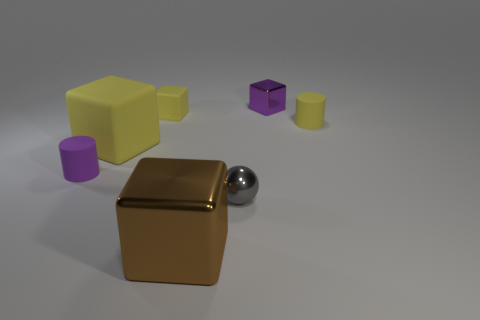Subtract all yellow balls. How many yellow blocks are left? 2 Subtract all big matte blocks. How many blocks are left? 3 Subtract all brown cubes. How many cubes are left? 3 Subtract 1 cubes. How many cubes are left? 3 Add 3 small metallic spheres. How many objects exist? 10 Subtract all green blocks. Subtract all gray balls. How many blocks are left? 4 Subtract all cubes. How many objects are left? 3 Subtract 0 green cylinders. How many objects are left? 7 Subtract all brown shiny blocks. Subtract all tiny cubes. How many objects are left? 4 Add 1 shiny blocks. How many shiny blocks are left? 3 